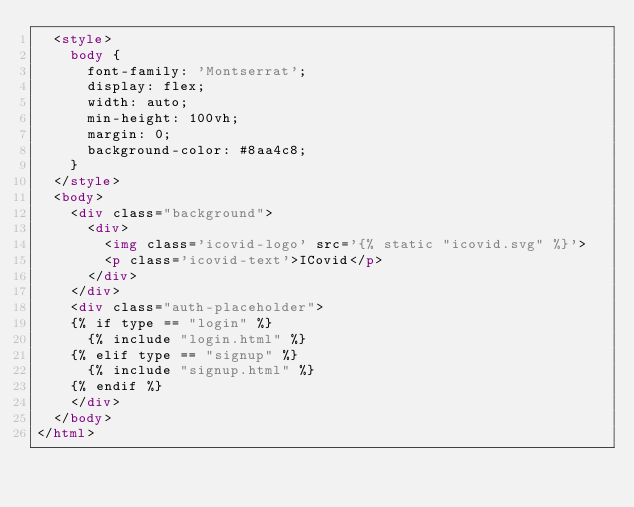Convert code to text. <code><loc_0><loc_0><loc_500><loc_500><_HTML_>  <style>
    body {
      font-family: 'Montserrat';
      display: flex;
      width: auto;
      min-height: 100vh;
      margin: 0;
      background-color: #8aa4c8;
    }
  </style>
  <body>
    <div class="background">
      <div>
        <img class='icovid-logo' src='{% static "icovid.svg" %}'>
        <p class='icovid-text'>ICovid</p>
      </div>
    </div>
    <div class="auth-placeholder">
    {% if type == "login" %}
      {% include "login.html" %} 
    {% elif type == "signup" %}
      {% include "signup.html" %} 
    {% endif %}
    </div>
  </body>
</html>
</code> 